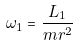<formula> <loc_0><loc_0><loc_500><loc_500>\omega _ { 1 } = \frac { L _ { 1 } } { m r ^ { 2 } }</formula> 